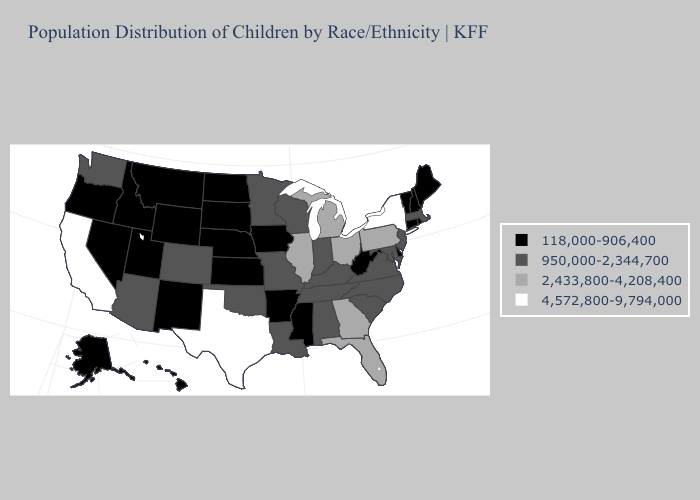Which states hav the highest value in the South?
Answer briefly. Texas. Name the states that have a value in the range 950,000-2,344,700?
Concise answer only. Alabama, Arizona, Colorado, Indiana, Kentucky, Louisiana, Maryland, Massachusetts, Minnesota, Missouri, New Jersey, North Carolina, Oklahoma, South Carolina, Tennessee, Virginia, Washington, Wisconsin. Which states hav the highest value in the South?
Short answer required. Texas. Does South Dakota have the lowest value in the USA?
Give a very brief answer. Yes. What is the value of New Mexico?
Give a very brief answer. 118,000-906,400. What is the highest value in states that border South Carolina?
Answer briefly. 2,433,800-4,208,400. Among the states that border Delaware , does Pennsylvania have the lowest value?
Be succinct. No. What is the lowest value in the Northeast?
Quick response, please. 118,000-906,400. Name the states that have a value in the range 118,000-906,400?
Keep it brief. Alaska, Arkansas, Connecticut, Delaware, Hawaii, Idaho, Iowa, Kansas, Maine, Mississippi, Montana, Nebraska, Nevada, New Hampshire, New Mexico, North Dakota, Oregon, Rhode Island, South Dakota, Utah, Vermont, West Virginia, Wyoming. Does New York have the highest value in the USA?
Give a very brief answer. Yes. What is the value of New York?
Be succinct. 4,572,800-9,794,000. Does Michigan have the same value as Illinois?
Short answer required. Yes. What is the value of Massachusetts?
Concise answer only. 950,000-2,344,700. What is the lowest value in the Northeast?
Keep it brief. 118,000-906,400. What is the highest value in the South ?
Give a very brief answer. 4,572,800-9,794,000. 